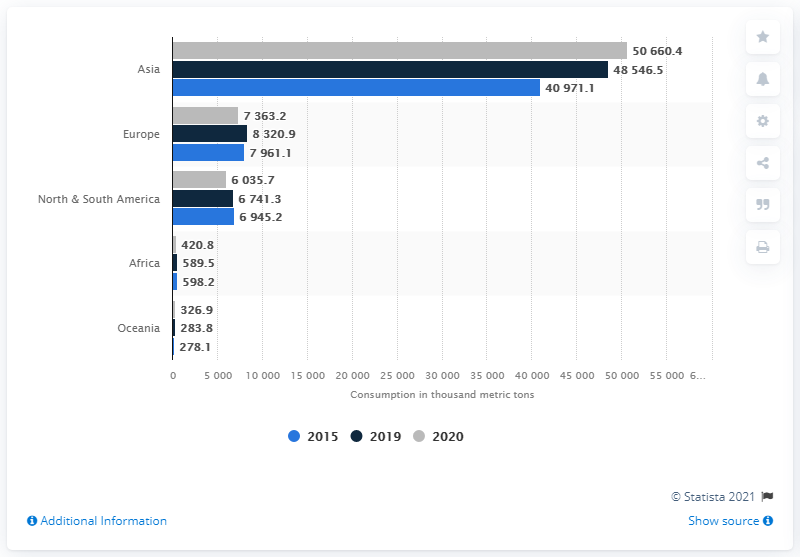Highlight a few significant elements in this photo. According to data from 2020, Europe was the second largest consumer of refined aluminum. Asia is the leading consuming region of refined aluminum in the world. 